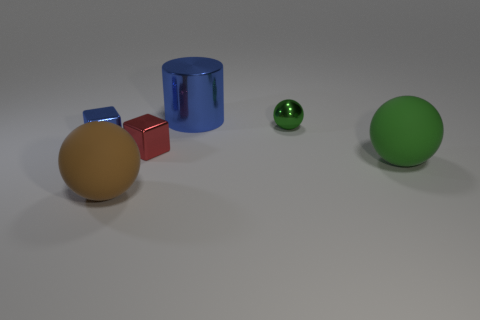What is the size of the rubber object that is the same color as the tiny metal sphere?
Offer a terse response. Large. There is a big metallic cylinder; does it have the same color as the tiny block left of the large brown ball?
Keep it short and to the point. Yes. What size is the metallic thing that is behind the green shiny object that is on the right side of the small blue block?
Provide a succinct answer. Large. How many objects are small blue cubes or blue things that are on the left side of the brown rubber object?
Your response must be concise. 1. There is a big matte thing that is on the right side of the brown ball; is it the same shape as the small red metallic object?
Provide a succinct answer. No. How many matte things are on the left side of the rubber sphere to the right of the tiny metal object that is in front of the tiny blue block?
Ensure brevity in your answer.  1. Is there any other thing that has the same shape as the large blue thing?
Make the answer very short. No. How many objects are either large green balls or big gray balls?
Provide a short and direct response. 1. There is a green matte object; is it the same shape as the small metal object that is behind the small blue metallic object?
Ensure brevity in your answer.  Yes. What is the shape of the matte object that is right of the tiny green ball?
Your answer should be very brief. Sphere. 